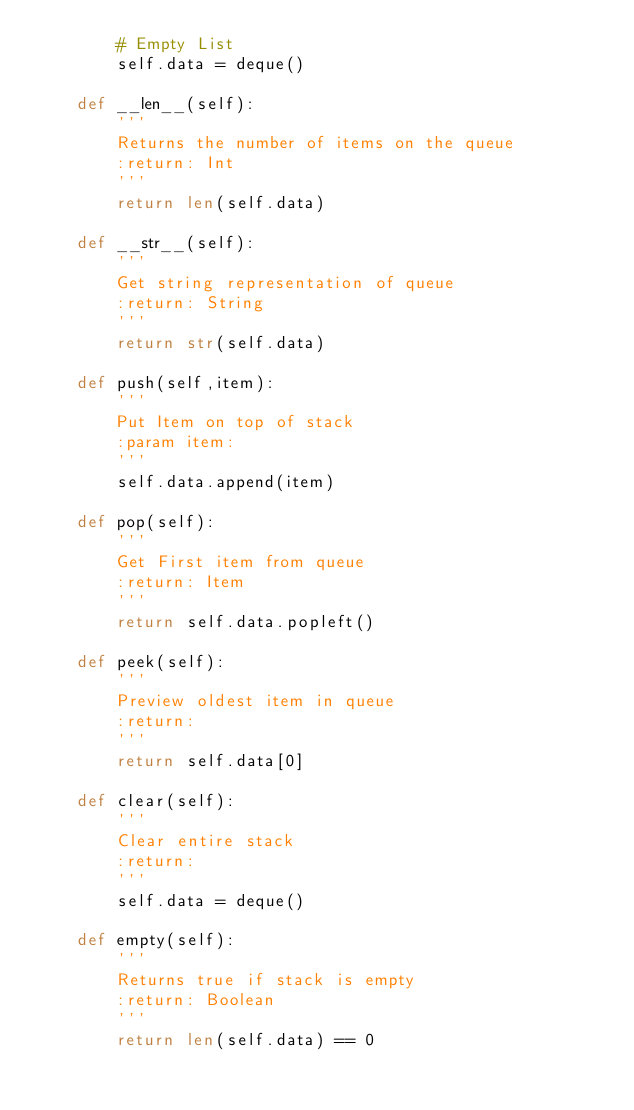Convert code to text. <code><loc_0><loc_0><loc_500><loc_500><_Python_>        # Empty List
        self.data = deque()

    def __len__(self):
        '''
        Returns the number of items on the queue
        :return: Int
        '''
        return len(self.data)

    def __str__(self):
        '''
        Get string representation of queue
        :return: String
        '''
        return str(self.data)

    def push(self,item):
        '''
        Put Item on top of stack
        :param item:
        '''
        self.data.append(item)

    def pop(self):
        '''
        Get First item from queue
        :return: Item
        '''
        return self.data.popleft()

    def peek(self):
        '''
        Preview oldest item in queue
        :return:
        '''
        return self.data[0]

    def clear(self):
        '''
        Clear entire stack
        :return:
        '''
        self.data = deque()

    def empty(self):
        '''
        Returns true if stack is empty
        :return: Boolean
        '''
        return len(self.data) == 0</code> 